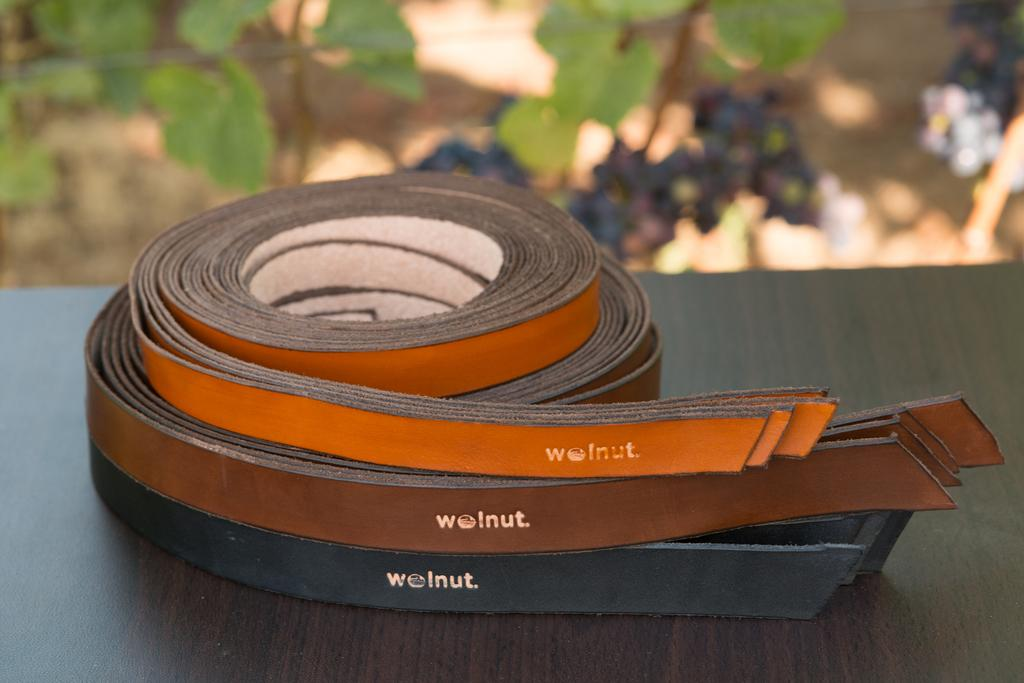What type of accessory is shown in the image? There are leather belts in the image. What colors are the belts? The belts are black, brown, and orange in color. Where are the belts placed in the image? The belts are placed on a wooden platform. What can be seen in the background of the image? There are plants visible in the background of the image. What type of cheese is being served on the throne in the image? There is no cheese or throne present in the image; it features leather belts placed on a wooden platform with plants in the background. 